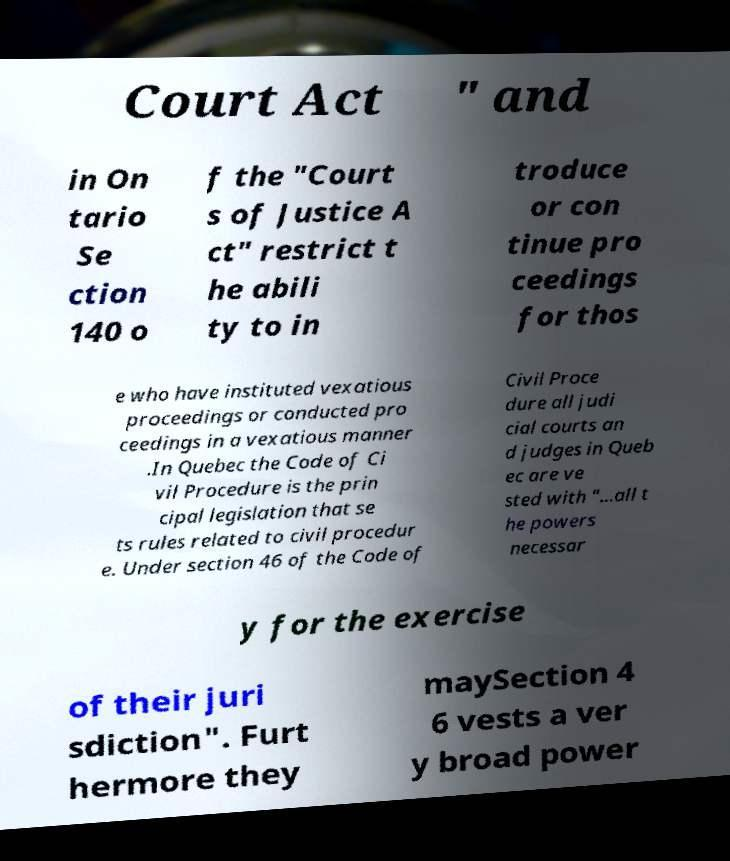For documentation purposes, I need the text within this image transcribed. Could you provide that? Court Act " and in On tario Se ction 140 o f the "Court s of Justice A ct" restrict t he abili ty to in troduce or con tinue pro ceedings for thos e who have instituted vexatious proceedings or conducted pro ceedings in a vexatious manner .In Quebec the Code of Ci vil Procedure is the prin cipal legislation that se ts rules related to civil procedur e. Under section 46 of the Code of Civil Proce dure all judi cial courts an d judges in Queb ec are ve sted with "...all t he powers necessar y for the exercise of their juri sdiction". Furt hermore they maySection 4 6 vests a ver y broad power 